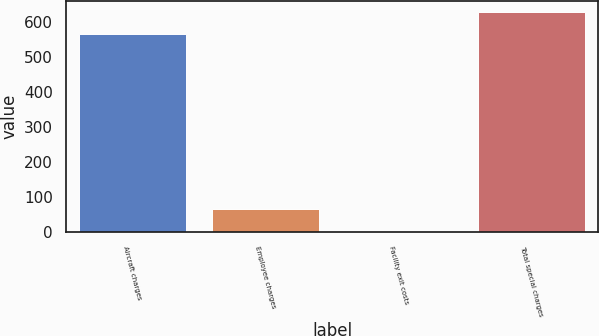Convert chart to OTSL. <chart><loc_0><loc_0><loc_500><loc_500><bar_chart><fcel>Aircraft charges<fcel>Employee charges<fcel>Facility exit costs<fcel>Total special charges<nl><fcel>565<fcel>65.2<fcel>3<fcel>627.2<nl></chart> 